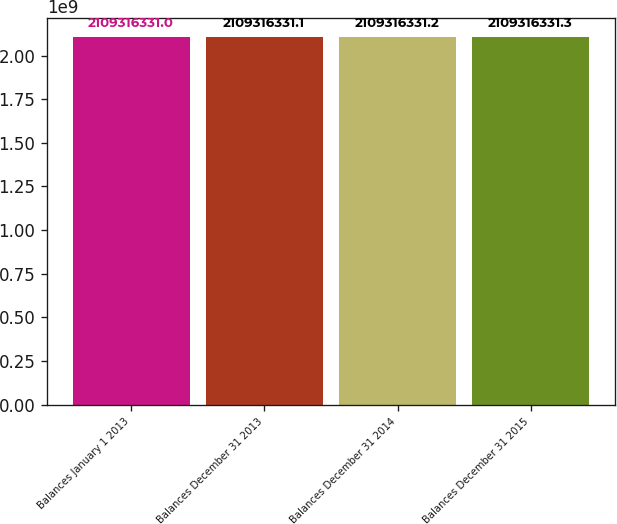Convert chart to OTSL. <chart><loc_0><loc_0><loc_500><loc_500><bar_chart><fcel>Balances January 1 2013<fcel>Balances December 31 2013<fcel>Balances December 31 2014<fcel>Balances December 31 2015<nl><fcel>2.10932e+09<fcel>2.10932e+09<fcel>2.10932e+09<fcel>2.10932e+09<nl></chart> 